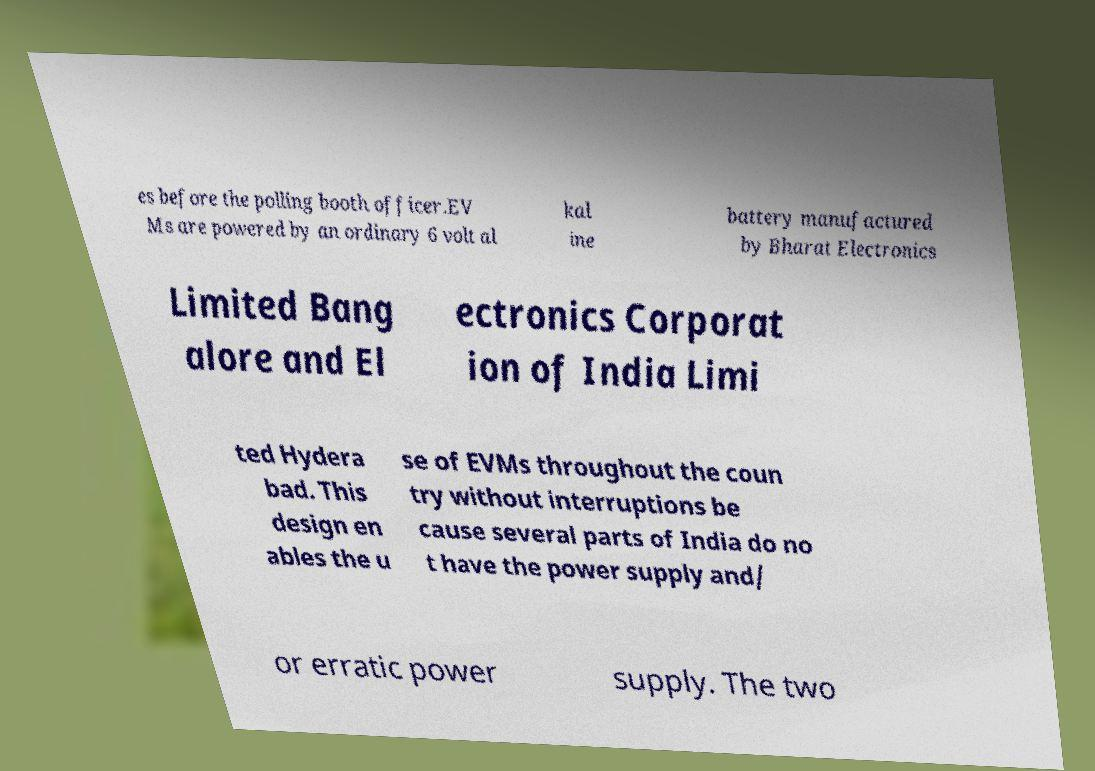For documentation purposes, I need the text within this image transcribed. Could you provide that? es before the polling booth officer.EV Ms are powered by an ordinary 6 volt al kal ine battery manufactured by Bharat Electronics Limited Bang alore and El ectronics Corporat ion of India Limi ted Hydera bad. This design en ables the u se of EVMs throughout the coun try without interruptions be cause several parts of India do no t have the power supply and/ or erratic power supply. The two 